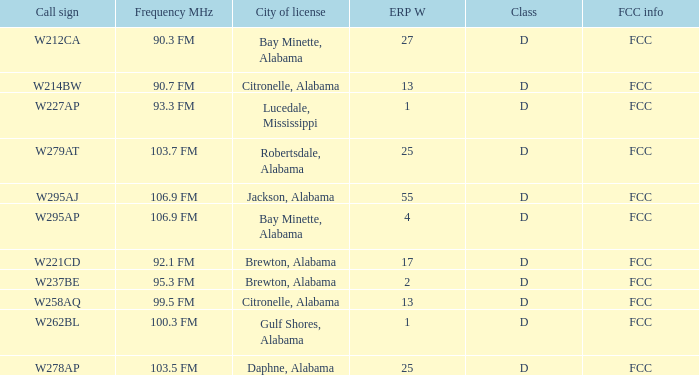Name the call sign for ERP W of 27 W212CA. 